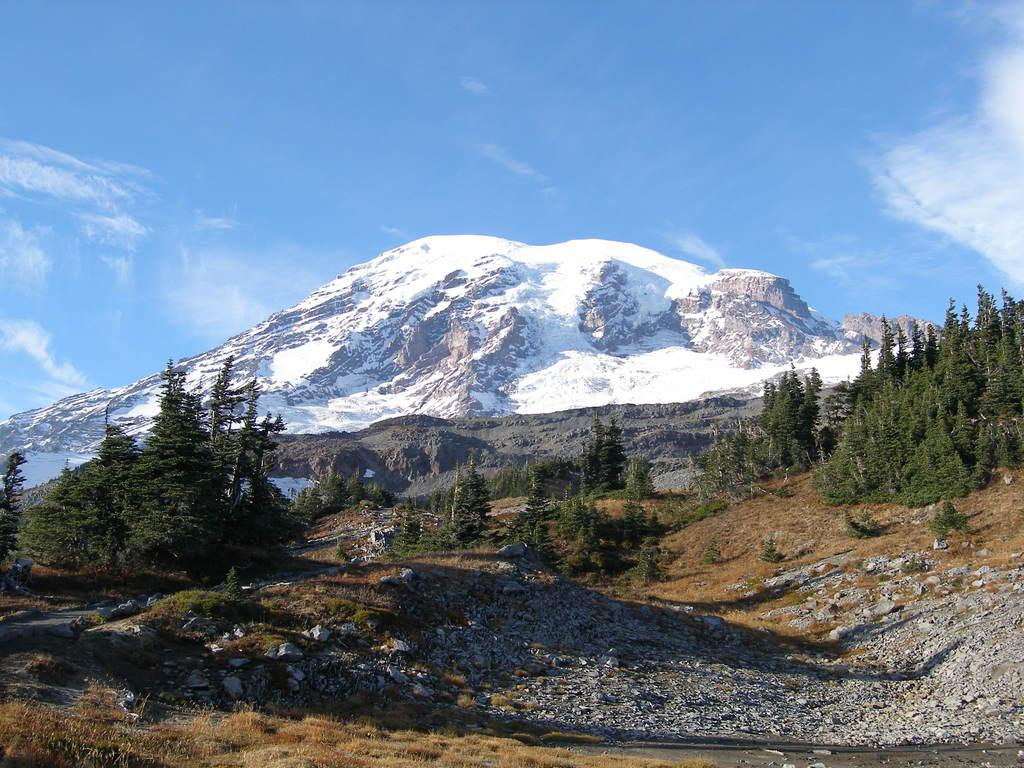What is located in the center of the image? There are trees in the center of the image. What can be seen in the background of the image? There are hills and the sky visible in the background of the image. How many rabbits can be seen hopping around in the image? There are no rabbits present in the image. What type of town is visible in the image? There is no town visible in the image; it features trees, hills, and the sky. 